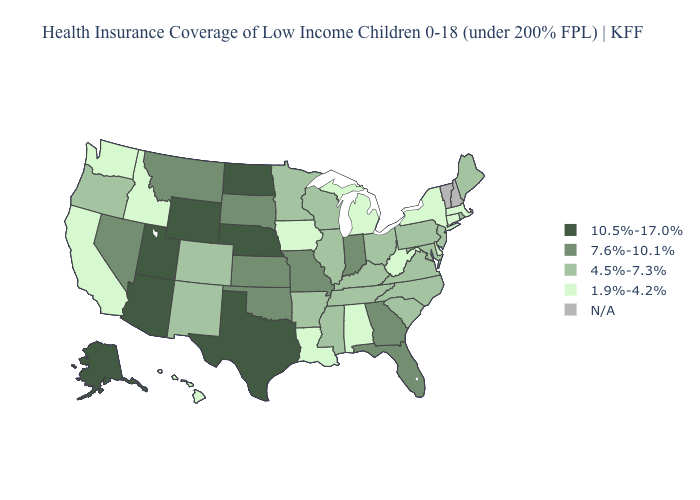What is the value of Alabama?
Concise answer only. 1.9%-4.2%. What is the value of Maine?
Be succinct. 4.5%-7.3%. Does Pennsylvania have the highest value in the Northeast?
Concise answer only. Yes. What is the value of Maine?
Be succinct. 4.5%-7.3%. What is the highest value in the West ?
Quick response, please. 10.5%-17.0%. What is the value of Texas?
Short answer required. 10.5%-17.0%. What is the lowest value in the USA?
Be succinct. 1.9%-4.2%. Name the states that have a value in the range N/A?
Write a very short answer. New Hampshire, Vermont. Is the legend a continuous bar?
Short answer required. No. Among the states that border California , does Oregon have the highest value?
Concise answer only. No. Does Florida have the lowest value in the South?
Quick response, please. No. Name the states that have a value in the range 10.5%-17.0%?
Short answer required. Alaska, Arizona, Nebraska, North Dakota, Texas, Utah, Wyoming. What is the highest value in the South ?
Short answer required. 10.5%-17.0%. Name the states that have a value in the range 10.5%-17.0%?
Answer briefly. Alaska, Arizona, Nebraska, North Dakota, Texas, Utah, Wyoming. 